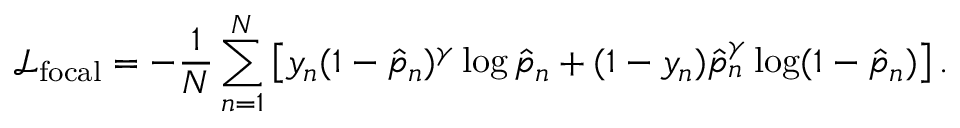<formula> <loc_0><loc_0><loc_500><loc_500>\mathcal { L } _ { f o c a l } = - \frac { 1 } { N } \sum _ { n = 1 } ^ { N } \left [ y _ { n } ( 1 - \hat { p } _ { n } ) ^ { \gamma } \log \hat { p } _ { n } + ( 1 - y _ { n } ) \hat { p } _ { n } ^ { \gamma } \log ( 1 - \hat { p } _ { n } ) \right ] .</formula> 